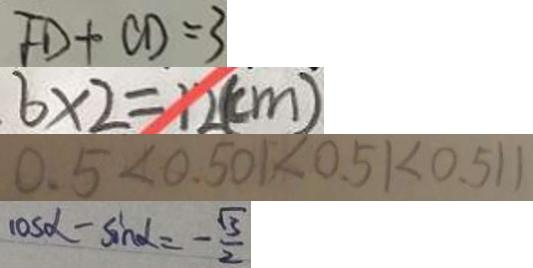<formula> <loc_0><loc_0><loc_500><loc_500>F D + C D = 3 
 6 \times 2 = 1 2 ( c m ) 
 0 . 5 < 0 . 5 0 1 < 0 . 5 1 < 0 . 5 1 1 
 \cos \alpha - \sin \alpha = - \frac { \sqrt { 3 } } { 2 }</formula> 